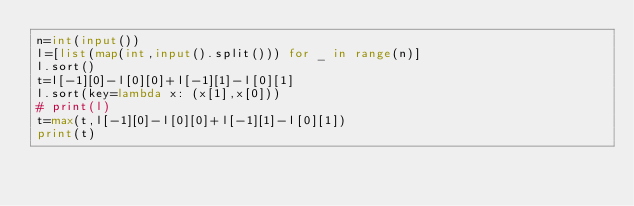Convert code to text. <code><loc_0><loc_0><loc_500><loc_500><_Python_>n=int(input())
l=[list(map(int,input().split())) for _ in range(n)]
l.sort()
t=l[-1][0]-l[0][0]+l[-1][1]-l[0][1]
l.sort(key=lambda x: (x[1],x[0]))
# print(l)
t=max(t,l[-1][0]-l[0][0]+l[-1][1]-l[0][1])
print(t)
</code> 